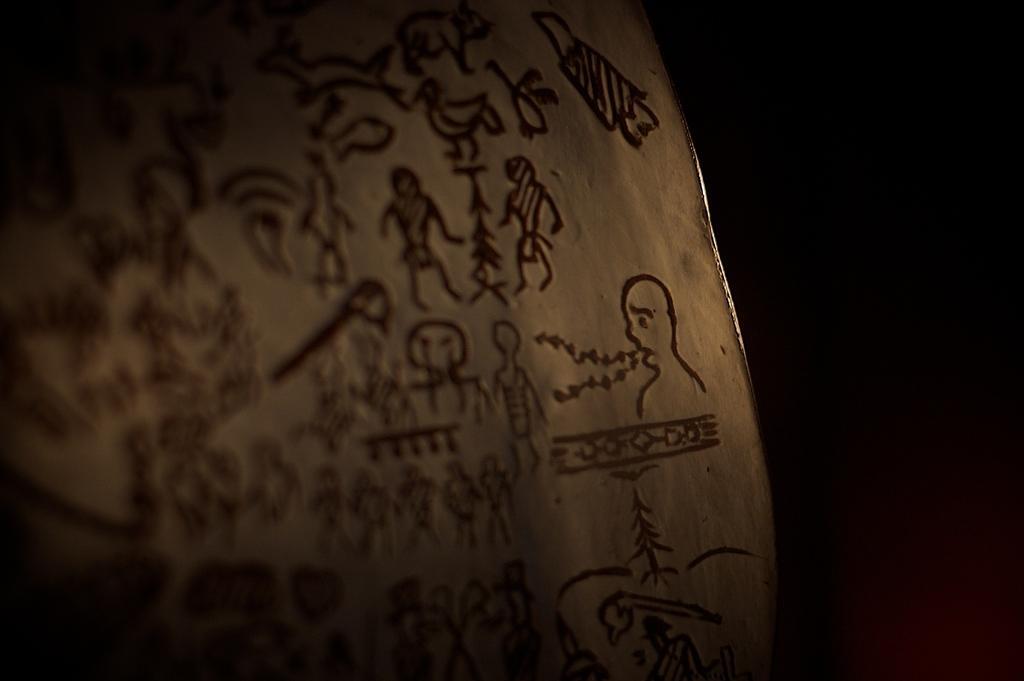Can you describe this image briefly? In this image we can see an object with some art and the background is dark. 